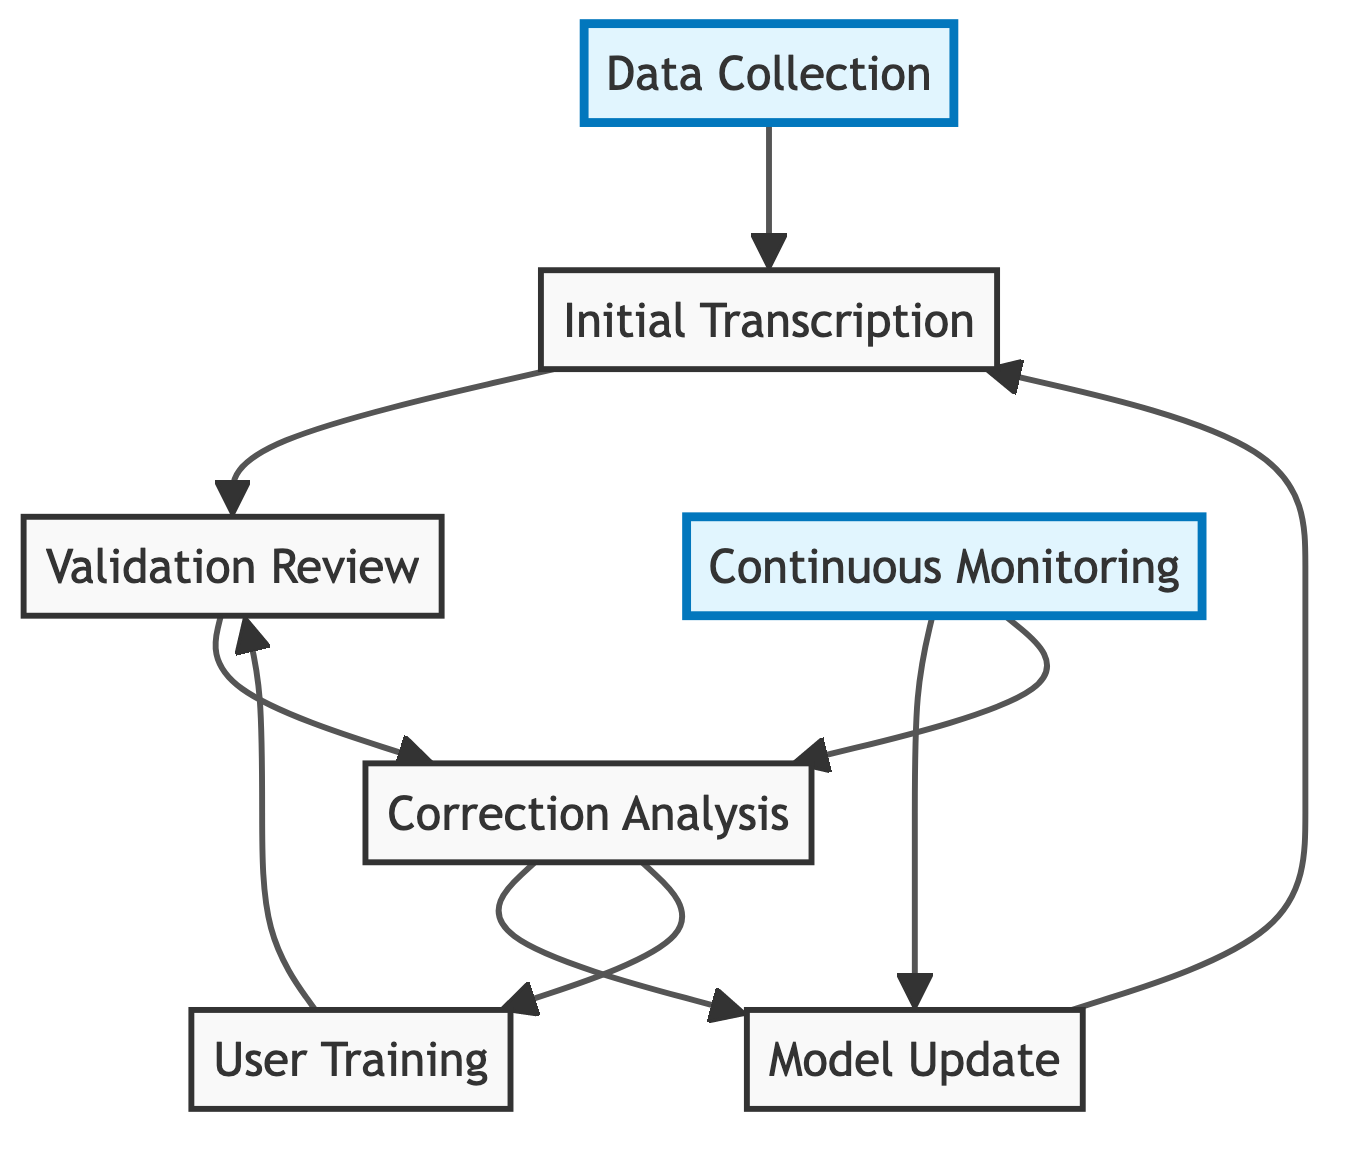What is the first step in the feedback loop? The first step is "Data Collection," which is the node that initiates the process by gathering raw audio data.
Answer: Data Collection How many nodes are connected to the "Correction Analysis"? There are two nodes connected to "Correction Analysis": "Model Update" and "User Training."
Answer: Two What is the process following "Model Update"? After "Model Update," the process follows back to "Initial Transcription," indicating that updated models are used for transcription.
Answer: Initial Transcription Which node is highlighted in the diagram? The nodes "Data Collection" and "Continuous Monitoring" are highlighted to signify their importance in the process.
Answer: Data Collection, Continuous Monitoring What feedback mechanism allows for continuous improvement? The "Continuous Monitoring" node represents the mechanism for ongoing oversight, ensuring transcription quality is consistently enhanced based on previous steps.
Answer: Continuous Monitoring What do "User Training" and "Validation Review" share in their connection? "User Training" connects back to "Validation Review," indicating that user training is aimed at improving the quality of validation reviews through better feedback.
Answer: Validation Review How does "Correction Analysis" influence the model? "Correction Analysis" provides insights into transcription errors that lead to the "Model Update," allowing the model to be refined based on user feedback.
Answer: Model Update What is the purpose of "Validation Review"? "Validation Review" serves to gather feedback from users or domain experts to identify errors in initial transcriptions, which is essential for quality improvement.
Answer: Identify errors What is the last step before feedback is applied to improve transcription? After "Correction Analysis," the last step involves the "Model Update" before the insights lead back to transcription processes.
Answer: Model Update 